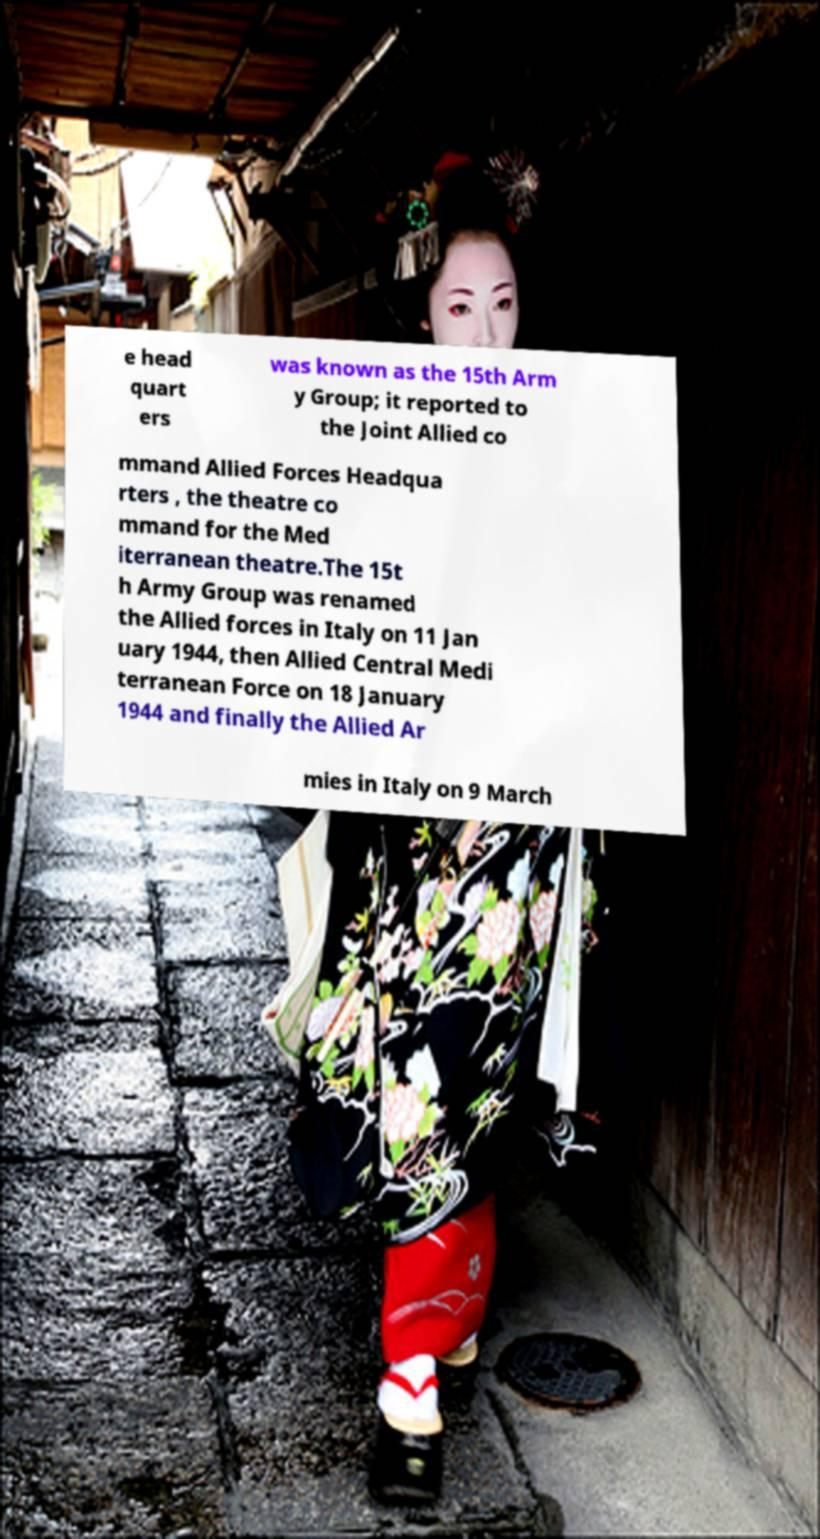Could you assist in decoding the text presented in this image and type it out clearly? e head quart ers was known as the 15th Arm y Group; it reported to the Joint Allied co mmand Allied Forces Headqua rters , the theatre co mmand for the Med iterranean theatre.The 15t h Army Group was renamed the Allied forces in Italy on 11 Jan uary 1944, then Allied Central Medi terranean Force on 18 January 1944 and finally the Allied Ar mies in Italy on 9 March 